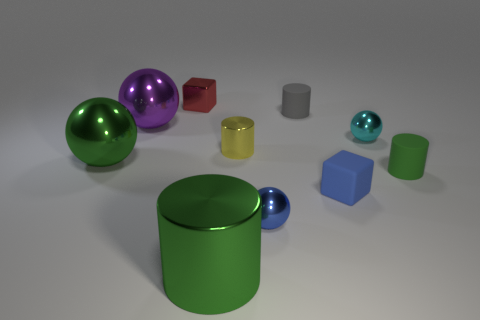Is the number of tiny green cylinders greater than the number of large yellow metallic cylinders?
Provide a succinct answer. Yes. What number of metal blocks are the same size as the gray cylinder?
Give a very brief answer. 1. There is a small matte object that is the same color as the big shiny cylinder; what shape is it?
Provide a short and direct response. Cylinder. How many things are metallic things that are right of the small yellow shiny cylinder or small gray objects?
Your answer should be compact. 3. Are there fewer cyan things than large blue things?
Provide a short and direct response. No. The tiny red object that is the same material as the cyan ball is what shape?
Ensure brevity in your answer.  Cube. Are there any tiny red blocks on the right side of the blue shiny ball?
Your answer should be compact. No. Are there fewer large purple objects that are behind the big purple object than tiny green matte cylinders?
Your answer should be compact. Yes. What is the tiny gray object made of?
Provide a succinct answer. Rubber. The matte block is what color?
Offer a terse response. Blue. 